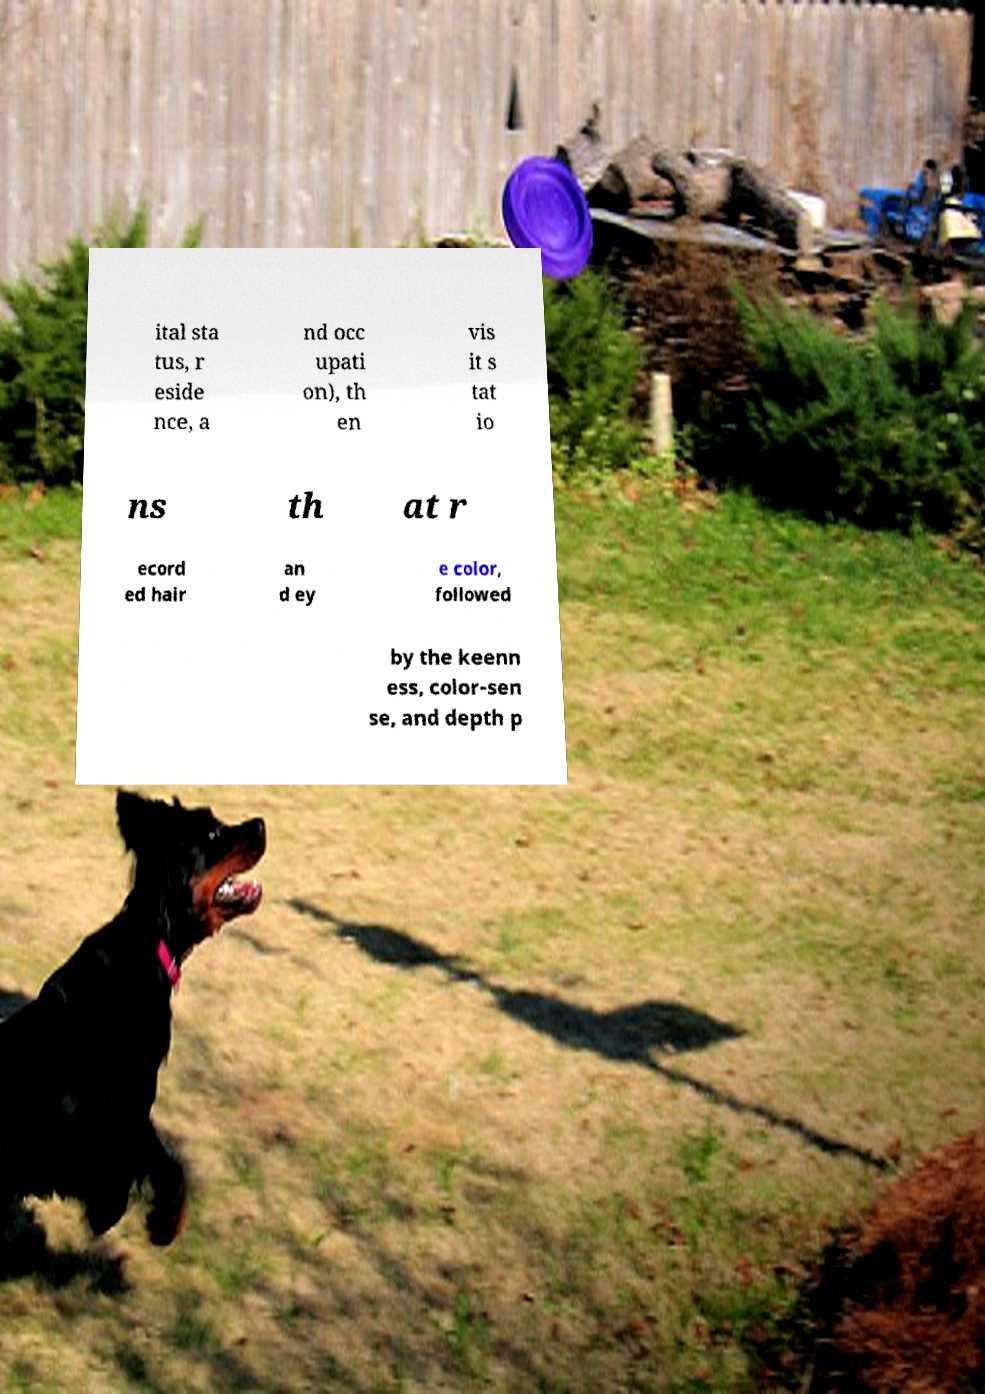Can you read and provide the text displayed in the image?This photo seems to have some interesting text. Can you extract and type it out for me? ital sta tus, r eside nce, a nd occ upati on), th en vis it s tat io ns th at r ecord ed hair an d ey e color, followed by the keenn ess, color-sen se, and depth p 